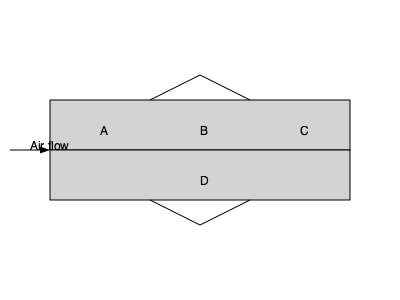In the simplified cross-sectional diagram of a jet engine above, which component (labeled A, B, C, or D) is responsible for increasing the pressure of the incoming air before it enters the combustion chamber? To answer this question, let's break down the basic components of a jet engine and their functions:

1. The diagram shows a simplified cross-section of a jet engine with four labeled components (A, B, C, and D).

2. The air flow direction is indicated from left to right.

3. Component A is at the front of the engine, where air enters. This is likely the intake or fan section.

4. Component B is in the middle, with narrowing passages above and below. This structure is characteristic of a compressor.

5. Component C is towards the rear of the engine, which is typically where the combustion chamber and turbine are located.

6. Component D is at the bottom, running the length of the engine, which is likely the engine casing or bypass duct.

7. In a jet engine, the component responsible for increasing the pressure of incoming air before it enters the combustion chamber is the compressor.

8. The compressor's function is to squeeze the incoming air, increasing its pressure and temperature, which makes the combustion process more efficient.

9. Based on its location and shape, component B matches the description and function of a compressor.

Therefore, the component responsible for increasing the pressure of the incoming air before it enters the combustion chamber is B.
Answer: B 